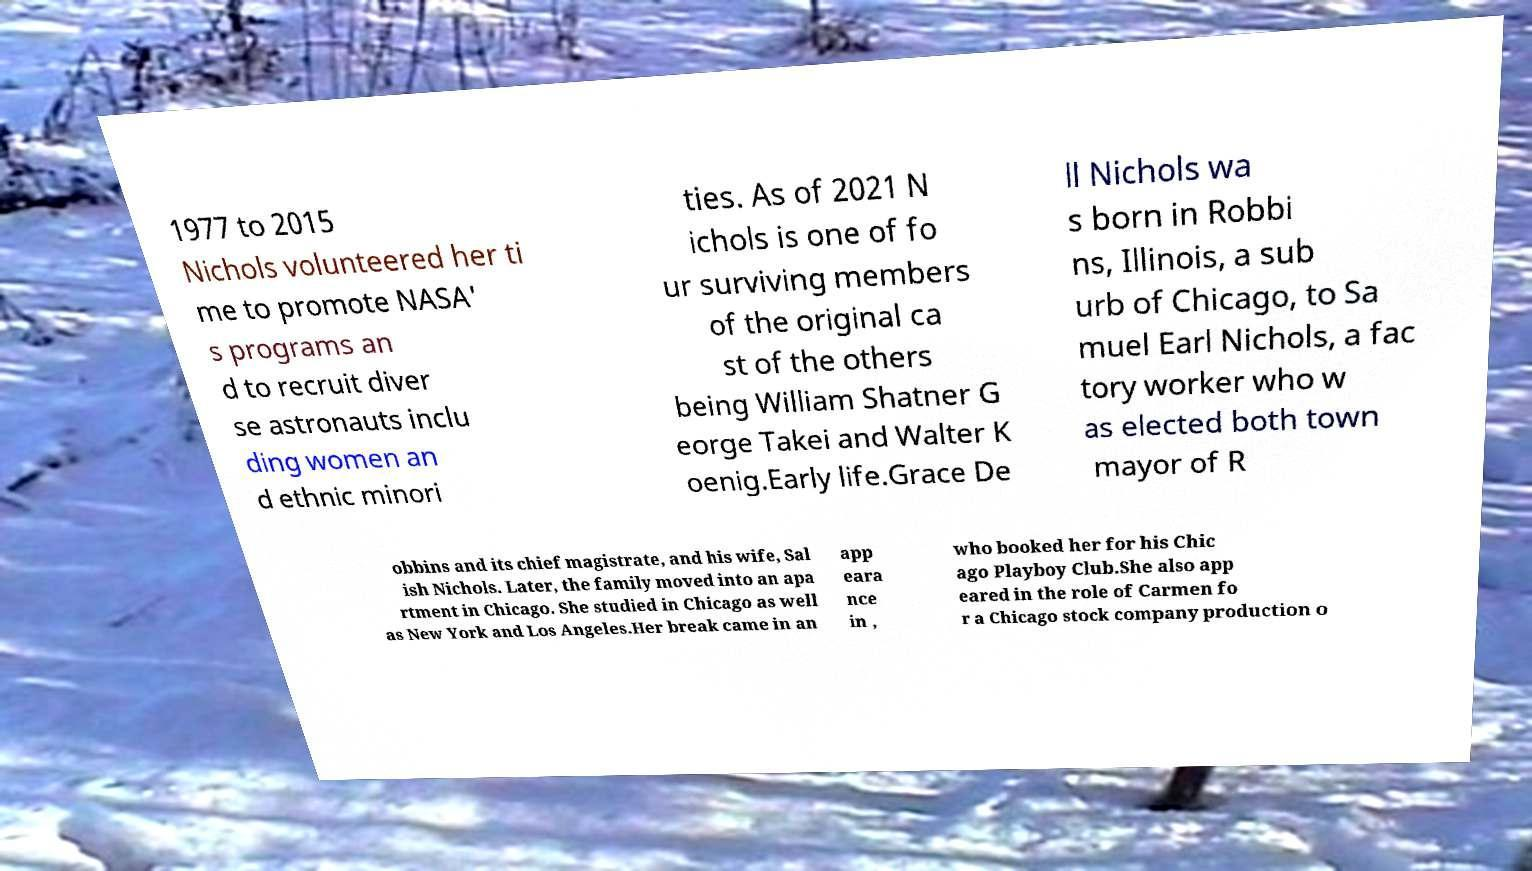Please identify and transcribe the text found in this image. 1977 to 2015 Nichols volunteered her ti me to promote NASA' s programs an d to recruit diver se astronauts inclu ding women an d ethnic minori ties. As of 2021 N ichols is one of fo ur surviving members of the original ca st of the others being William Shatner G eorge Takei and Walter K oenig.Early life.Grace De ll Nichols wa s born in Robbi ns, Illinois, a sub urb of Chicago, to Sa muel Earl Nichols, a fac tory worker who w as elected both town mayor of R obbins and its chief magistrate, and his wife, Sal ish Nichols. Later, the family moved into an apa rtment in Chicago. She studied in Chicago as well as New York and Los Angeles.Her break came in an app eara nce in , who booked her for his Chic ago Playboy Club.She also app eared in the role of Carmen fo r a Chicago stock company production o 